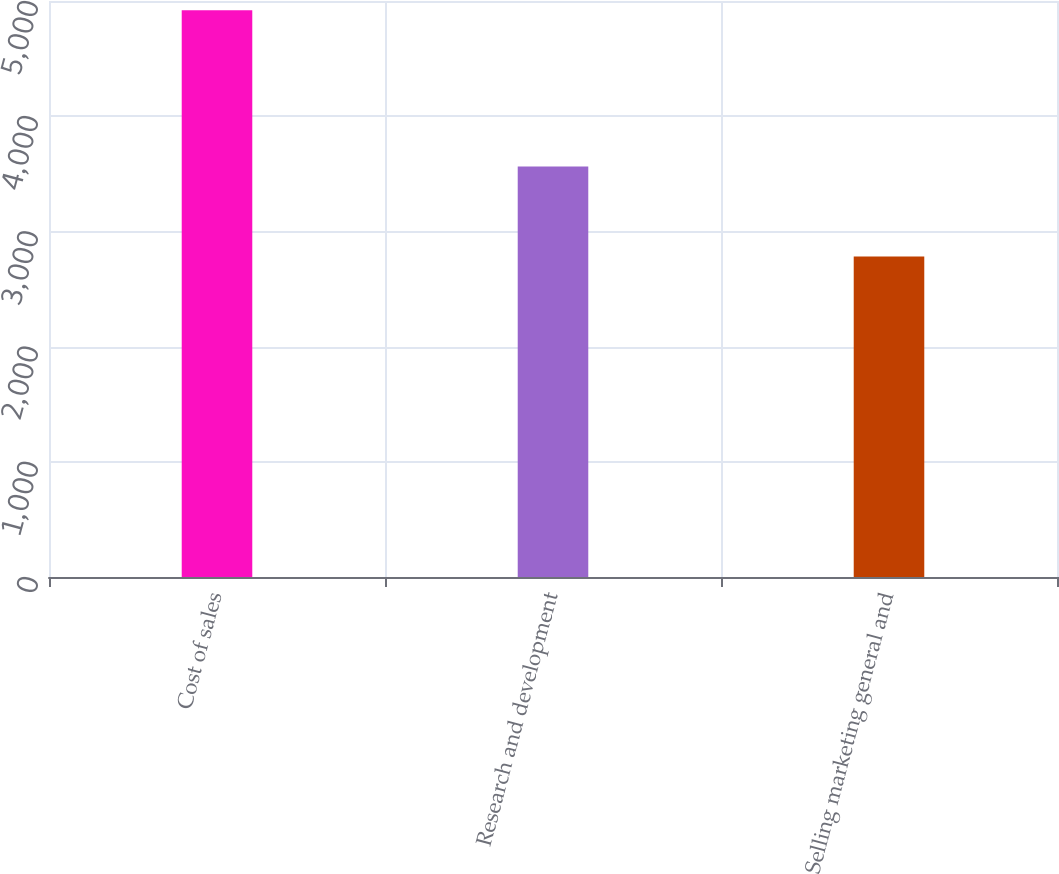Convert chart to OTSL. <chart><loc_0><loc_0><loc_500><loc_500><bar_chart><fcel>Cost of sales<fcel>Research and development<fcel>Selling marketing general and<nl><fcel>4920<fcel>3564<fcel>2782<nl></chart> 